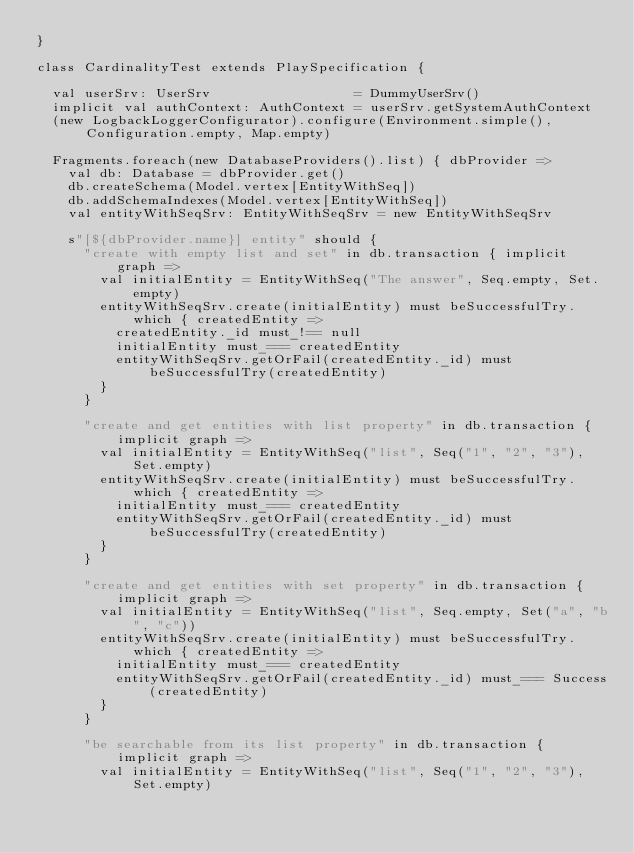Convert code to text. <code><loc_0><loc_0><loc_500><loc_500><_Scala_>}

class CardinalityTest extends PlaySpecification {

  val userSrv: UserSrv                  = DummyUserSrv()
  implicit val authContext: AuthContext = userSrv.getSystemAuthContext
  (new LogbackLoggerConfigurator).configure(Environment.simple(), Configuration.empty, Map.empty)

  Fragments.foreach(new DatabaseProviders().list) { dbProvider =>
    val db: Database = dbProvider.get()
    db.createSchema(Model.vertex[EntityWithSeq])
    db.addSchemaIndexes(Model.vertex[EntityWithSeq])
    val entityWithSeqSrv: EntityWithSeqSrv = new EntityWithSeqSrv

    s"[${dbProvider.name}] entity" should {
      "create with empty list and set" in db.transaction { implicit graph =>
        val initialEntity = EntityWithSeq("The answer", Seq.empty, Set.empty)
        entityWithSeqSrv.create(initialEntity) must beSuccessfulTry.which { createdEntity =>
          createdEntity._id must_!== null
          initialEntity must_=== createdEntity
          entityWithSeqSrv.getOrFail(createdEntity._id) must beSuccessfulTry(createdEntity)
        }
      }

      "create and get entities with list property" in db.transaction { implicit graph =>
        val initialEntity = EntityWithSeq("list", Seq("1", "2", "3"), Set.empty)
        entityWithSeqSrv.create(initialEntity) must beSuccessfulTry.which { createdEntity =>
          initialEntity must_=== createdEntity
          entityWithSeqSrv.getOrFail(createdEntity._id) must beSuccessfulTry(createdEntity)
        }
      }

      "create and get entities with set property" in db.transaction { implicit graph =>
        val initialEntity = EntityWithSeq("list", Seq.empty, Set("a", "b", "c"))
        entityWithSeqSrv.create(initialEntity) must beSuccessfulTry.which { createdEntity =>
          initialEntity must_=== createdEntity
          entityWithSeqSrv.getOrFail(createdEntity._id) must_=== Success(createdEntity)
        }
      }

      "be searchable from its list property" in db.transaction { implicit graph =>
        val initialEntity = EntityWithSeq("list", Seq("1", "2", "3"), Set.empty)</code> 